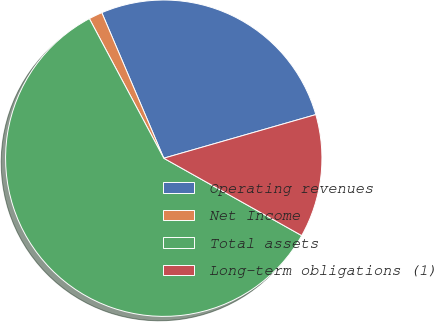Convert chart to OTSL. <chart><loc_0><loc_0><loc_500><loc_500><pie_chart><fcel>Operating revenues<fcel>Net Income<fcel>Total assets<fcel>Long-term obligations (1)<nl><fcel>26.96%<fcel>1.39%<fcel>59.07%<fcel>12.58%<nl></chart> 